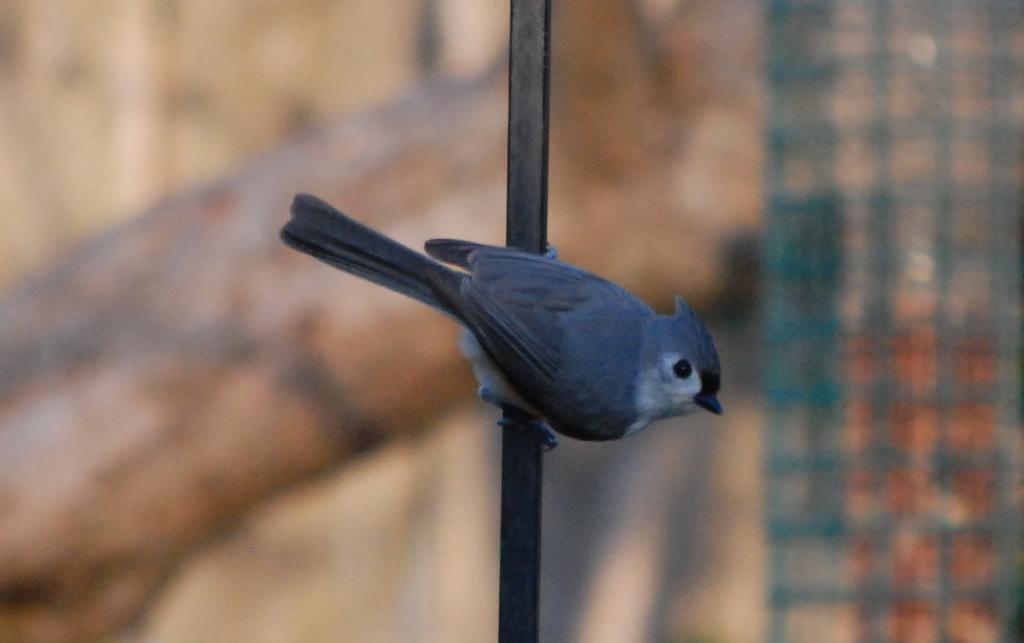Describe this image in one or two sentences. In the middle of the picture, we see a bird is on the black color rod. On the right side, we see a green color fence. In the background, we see the wooden log. This picture is blurred in the background. 